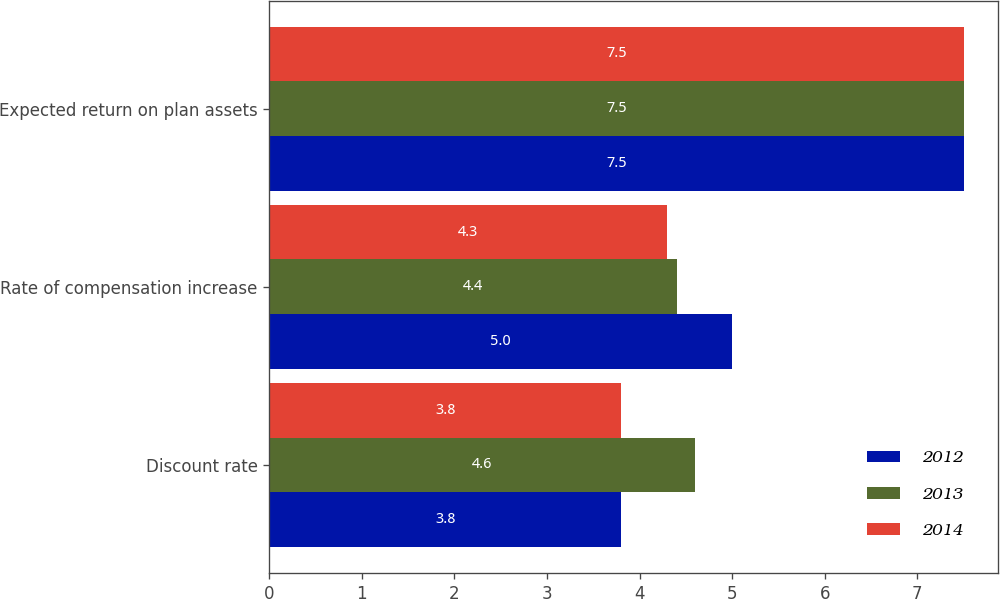Convert chart. <chart><loc_0><loc_0><loc_500><loc_500><stacked_bar_chart><ecel><fcel>Discount rate<fcel>Rate of compensation increase<fcel>Expected return on plan assets<nl><fcel>2012<fcel>3.8<fcel>5<fcel>7.5<nl><fcel>2013<fcel>4.6<fcel>4.4<fcel>7.5<nl><fcel>2014<fcel>3.8<fcel>4.3<fcel>7.5<nl></chart> 